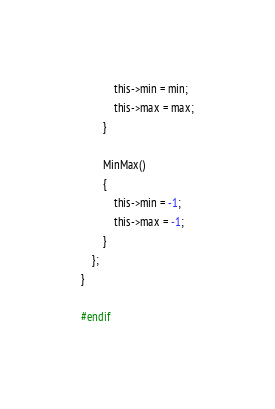Convert code to text. <code><loc_0><loc_0><loc_500><loc_500><_C_>            this->min = min;
            this->max = max;
        }

        MinMax()
        {
            this->min = -1;
            this->max = -1;
        }
    };
}

#endif
</code> 